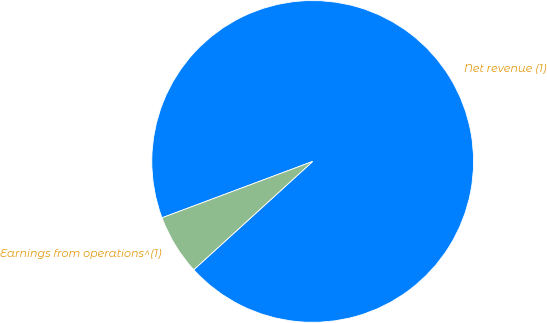Convert chart. <chart><loc_0><loc_0><loc_500><loc_500><pie_chart><fcel>Net revenue (1)<fcel>Earnings from operations^(1)<nl><fcel>93.94%<fcel>6.06%<nl></chart> 